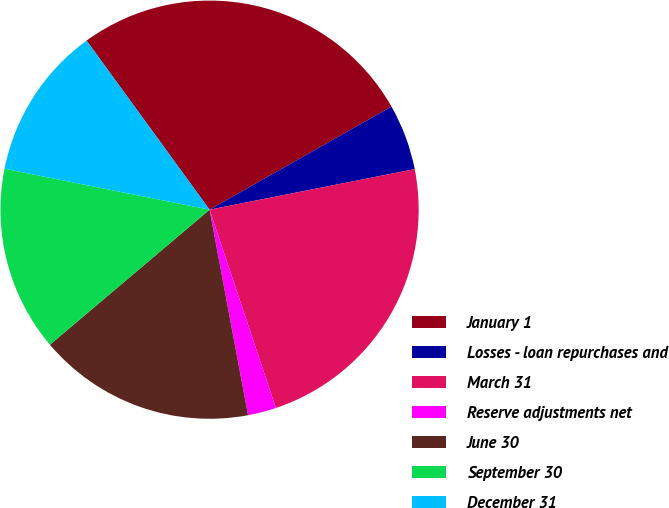Convert chart. <chart><loc_0><loc_0><loc_500><loc_500><pie_chart><fcel>January 1<fcel>Losses - loan repurchases and<fcel>March 31<fcel>Reserve adjustments net<fcel>June 30<fcel>September 30<fcel>December 31<nl><fcel>26.8%<fcel>5.1%<fcel>22.97%<fcel>2.19%<fcel>16.77%<fcel>14.31%<fcel>11.85%<nl></chart> 